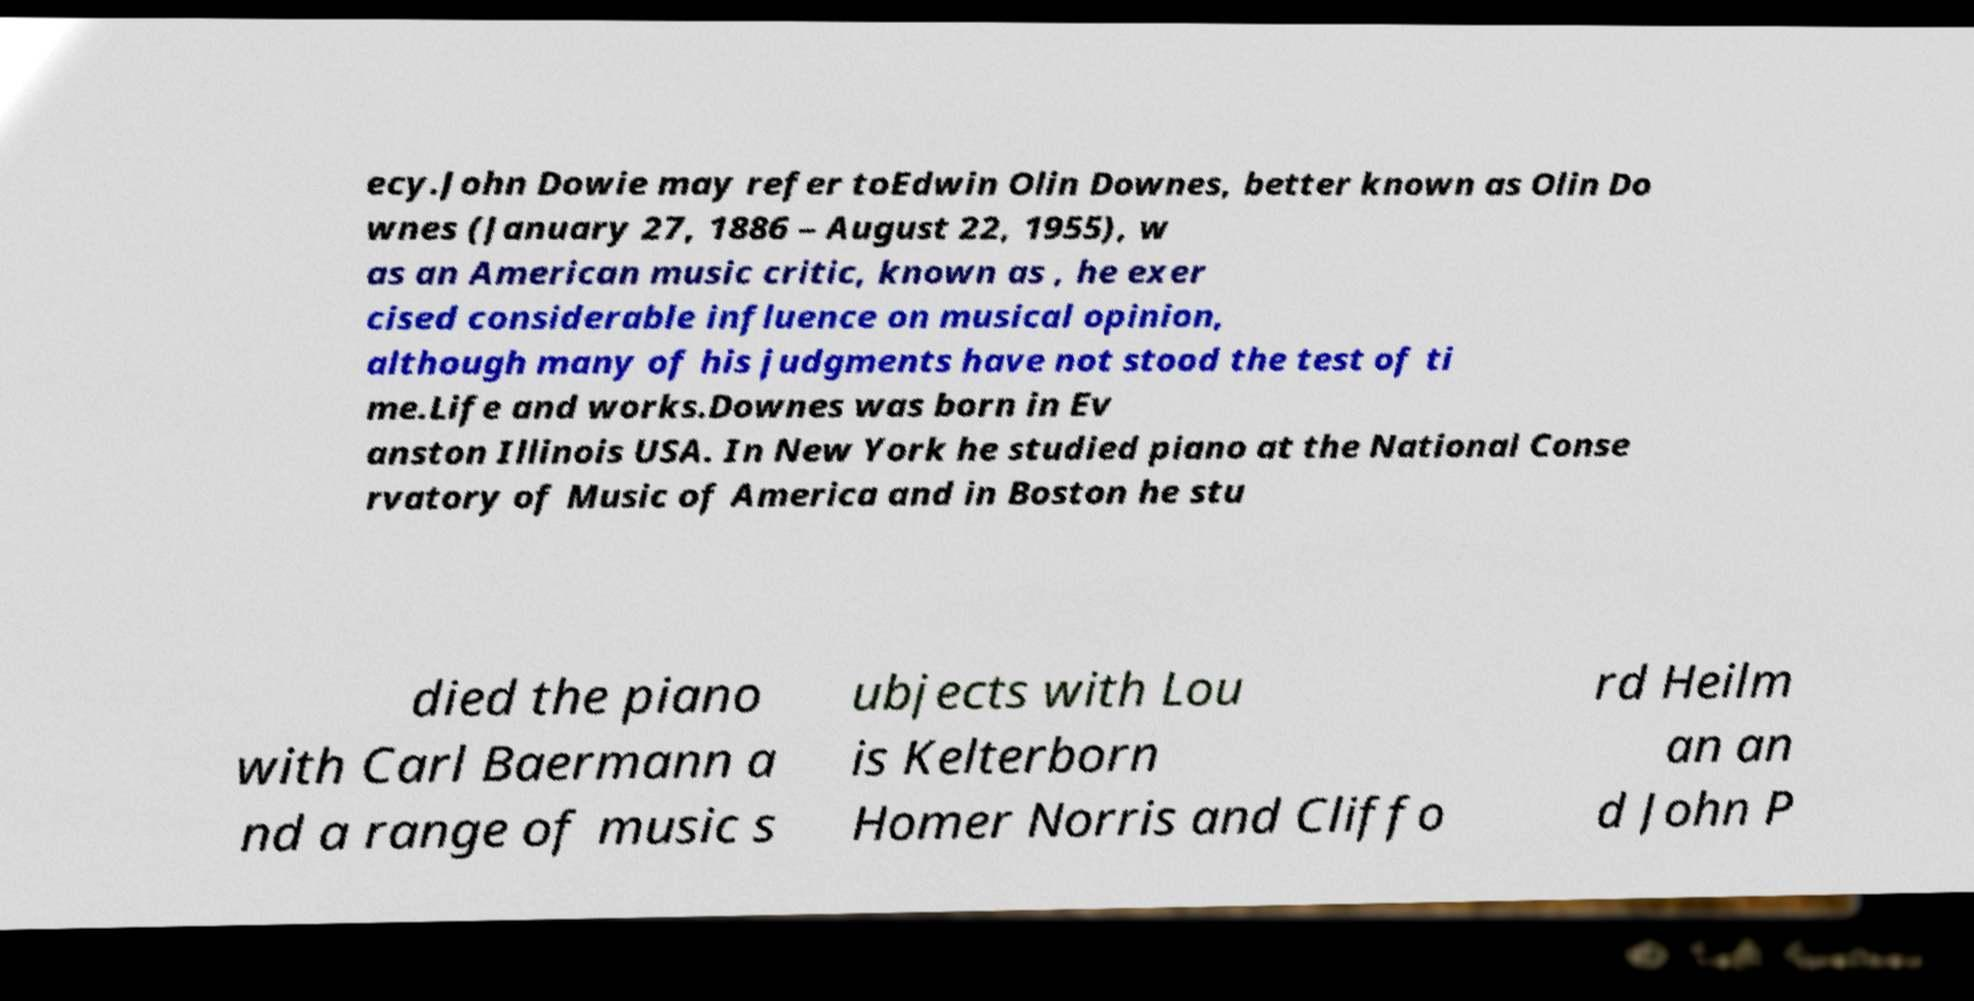What messages or text are displayed in this image? I need them in a readable, typed format. ecy.John Dowie may refer toEdwin Olin Downes, better known as Olin Do wnes (January 27, 1886 – August 22, 1955), w as an American music critic, known as , he exer cised considerable influence on musical opinion, although many of his judgments have not stood the test of ti me.Life and works.Downes was born in Ev anston Illinois USA. In New York he studied piano at the National Conse rvatory of Music of America and in Boston he stu died the piano with Carl Baermann a nd a range of music s ubjects with Lou is Kelterborn Homer Norris and Cliffo rd Heilm an an d John P 